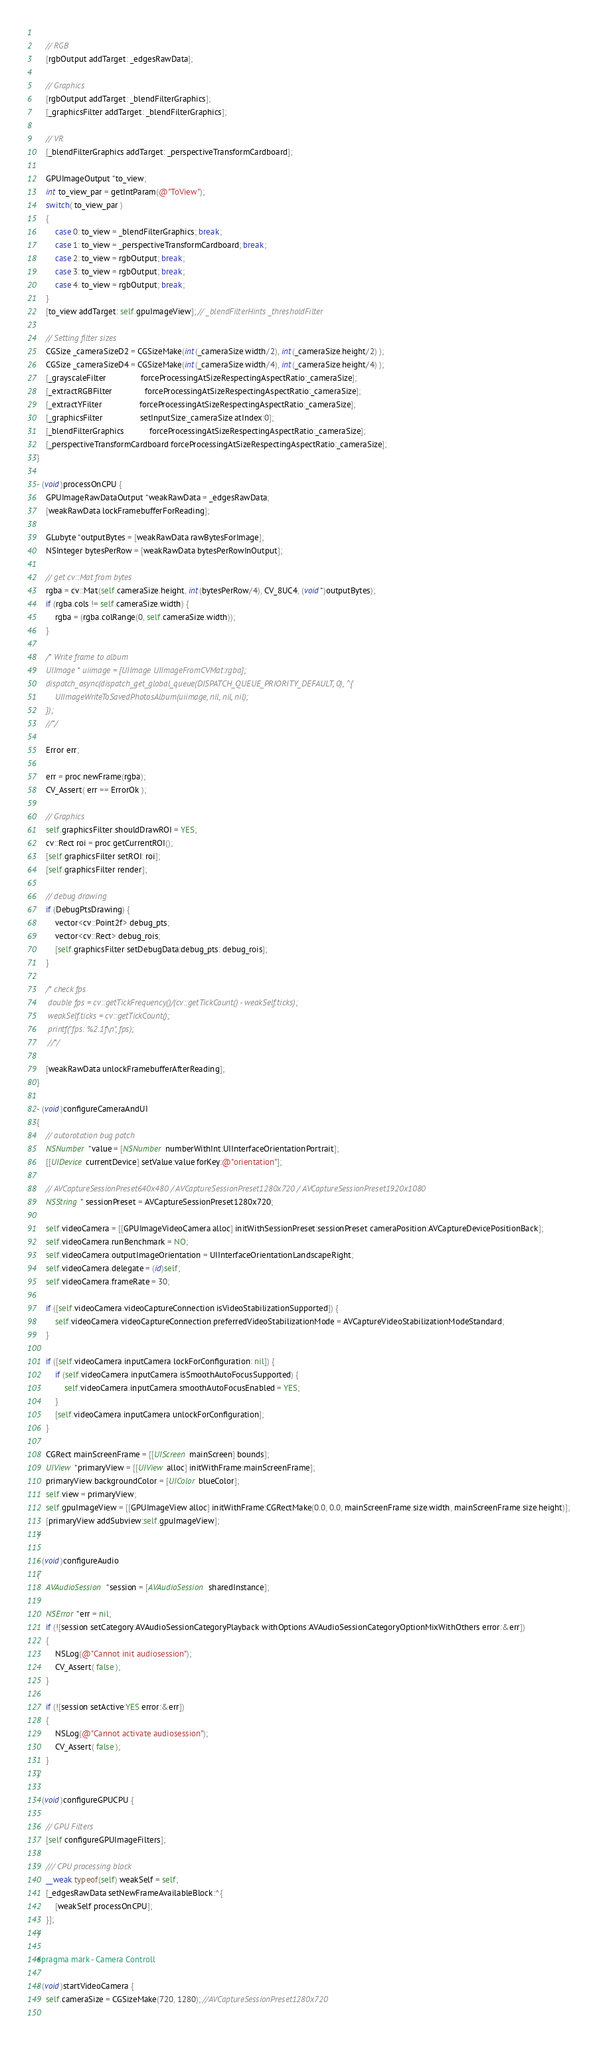<code> <loc_0><loc_0><loc_500><loc_500><_ObjectiveC_>    
    // RGB
    [rgbOutput addTarget: _edgesRawData];
    
    // Graphics
    [rgbOutput addTarget: _blendFilterGraphics];
    [_graphicsFilter addTarget: _blendFilterGraphics];
    
    // VR
    [_blendFilterGraphics addTarget: _perspectiveTransformCardboard];
    
    GPUImageOutput *to_view;
    int to_view_par = getIntParam(@"ToView");
    switch( to_view_par )
    {
        case 0: to_view = _blendFilterGraphics; break;
        case 1: to_view = _perspectiveTransformCardboard; break;
        case 2: to_view = rgbOutput; break;
        case 3: to_view = rgbOutput; break;
        case 4: to_view = rgbOutput; break;
    }
    [to_view addTarget: self.gpuImageView]; // _blendFilterHints _thresholdFilter
    
    // Setting filter sizes
    CGSize _cameraSizeD2 = CGSizeMake(int(_cameraSize.width/2), int(_cameraSize.height/2) );
    CGSize _cameraSizeD4 = CGSizeMake(int(_cameraSize.width/4), int(_cameraSize.height/4) );
    [_grayscaleFilter               forceProcessingAtSizeRespectingAspectRatio:_cameraSize];
    [_extractRGBFilter              forceProcessingAtSizeRespectingAspectRatio:_cameraSize];
    [_extractYFilter                forceProcessingAtSizeRespectingAspectRatio:_cameraSize];
    [_graphicsFilter                setInputSize:_cameraSize atIndex:0];
    [_blendFilterGraphics           forceProcessingAtSizeRespectingAspectRatio:_cameraSize];
    [_perspectiveTransformCardboard forceProcessingAtSizeRespectingAspectRatio:_cameraSize];
}

- (void)processOnCPU {
    GPUImageRawDataOutput *weakRawData = _edgesRawData;
    [weakRawData lockFramebufferForReading];
    
    GLubyte *outputBytes = [weakRawData rawBytesForImage];
    NSInteger bytesPerRow = [weakRawData bytesPerRowInOutput];
    
    // get cv::Mat from bytes
    rgba = cv::Mat(self.cameraSize.height, int(bytesPerRow/4), CV_8UC4, (void*)outputBytes);
    if (rgba.cols != self.cameraSize.width) {
        rgba = (rgba.colRange(0, self.cameraSize.width));
    }
    
    /* Write frame to album
    UIImage * uiimage = [UIImage UIImageFromCVMat:rgba];
    dispatch_async(dispatch_get_global_queue(DISPATCH_QUEUE_PRIORITY_DEFAULT, 0), ^{
        UIImageWriteToSavedPhotosAlbum(uiimage, nil, nil, nil);
    });
    //*/
    
    Error err;
    
    err = proc.newFrame(rgba);
    CV_Assert( err == ErrorOk );
    
    // Graphics
    self.graphicsFilter.shouldDrawROI = YES;
    cv::Rect roi = proc.getCurrentROI();
    [self.graphicsFilter setROI: roi];
    [self.graphicsFilter render];
    
    // debug drawing
    if (DebugPtsDrawing) {
        vector<cv::Point2f> debug_pts;
        vector<cv::Rect> debug_rois;
        [self.graphicsFilter setDebugData:debug_pts: debug_rois];
    }
    
    /* check fps
     double fps = cv::getTickFrequency()/(cv::getTickCount() - weakSelf.ticks);
     weakSelf.ticks = cv::getTickCount();
     printf("fps: %2.1f\n", fps);
     //*/
    
    [weakRawData unlockFramebufferAfterReading];
}

- (void)configureCameraAndUI
{
    // autorotation bug patch
    NSNumber *value = [NSNumber numberWithInt:UIInterfaceOrientationPortrait];
    [[UIDevice currentDevice] setValue:value forKey:@"orientation"];
    
    // AVCaptureSessionPreset640x480 / AVCaptureSessionPreset1280x720 / AVCaptureSessionPreset1920x1080
    NSString * sessionPreset = AVCaptureSessionPreset1280x720;
    
    self.videoCamera = [[GPUImageVideoCamera alloc] initWithSessionPreset:sessionPreset cameraPosition:AVCaptureDevicePositionBack];
    self.videoCamera.runBenchmark = NO;
    self.videoCamera.outputImageOrientation = UIInterfaceOrientationLandscapeRight;
    self.videoCamera.delegate = (id)self;
    self.videoCamera.frameRate = 30;
    
    if ([self.videoCamera.videoCaptureConnection isVideoStabilizationSupported]) {
        self.videoCamera.videoCaptureConnection.preferredVideoStabilizationMode = AVCaptureVideoStabilizationModeStandard;
    }
    
    if ([self.videoCamera.inputCamera lockForConfiguration: nil]) {
        if (self.videoCamera.inputCamera.isSmoothAutoFocusSupported) {
            self.videoCamera.inputCamera.smoothAutoFocusEnabled = YES;
        }
        [self.videoCamera.inputCamera unlockForConfiguration];
    }
    
    CGRect mainScreenFrame = [[UIScreen mainScreen] bounds];
    UIView *primaryView = [[UIView alloc] initWithFrame:mainScreenFrame];
    primaryView.backgroundColor = [UIColor blueColor];
    self.view = primaryView;
    self.gpuImageView = [[GPUImageView alloc] initWithFrame:CGRectMake(0.0, 0.0, mainScreenFrame.size.width, mainScreenFrame.size.height)];
    [primaryView addSubview:self.gpuImageView];
}

- (void)configureAudio
{
    AVAudioSession *session = [AVAudioSession sharedInstance];
    
    NSError *err = nil;
    if (![session setCategory:AVAudioSessionCategoryPlayback withOptions:AVAudioSessionCategoryOptionMixWithOthers error:&err])
    {
        NSLog(@"Cannot init audiosession");
        CV_Assert( false );
    }
    
    if (![session setActive:YES error:&err])
    {
        NSLog(@"Cannot activate audiosession");
        CV_Assert( false );
    }
}
    
- (void)configureGPUCPU {
    
    // GPU Filters
    [self configureGPUImageFilters];
    
    /// CPU processing block
    __weak typeof(self) weakSelf = self;
    [_edgesRawData setNewFrameAvailableBlock:^{
        [weakSelf processOnCPU];
    }];
}
    
#pragma mark - Camera Controll
    
- (void)startVideoCamera {
    self.cameraSize = CGSizeMake(720, 1280); //AVCaptureSessionPreset1280x720
    </code> 